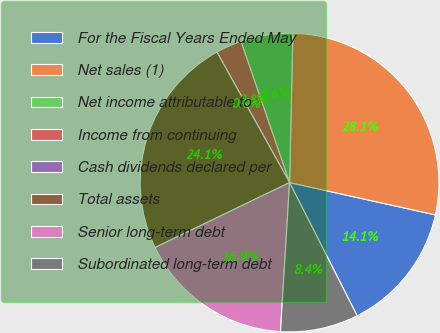Convert chart to OTSL. <chart><loc_0><loc_0><loc_500><loc_500><pie_chart><fcel>For the Fiscal Years Ended May<fcel>Net sales (1)<fcel>Net income attributable to<fcel>Income from continuing<fcel>Cash dividends declared per<fcel>Total assets<fcel>Senior long-term debt<fcel>Subordinated long-term debt<nl><fcel>14.06%<fcel>28.12%<fcel>5.63%<fcel>2.81%<fcel>0.0%<fcel>24.07%<fcel>16.87%<fcel>8.44%<nl></chart> 